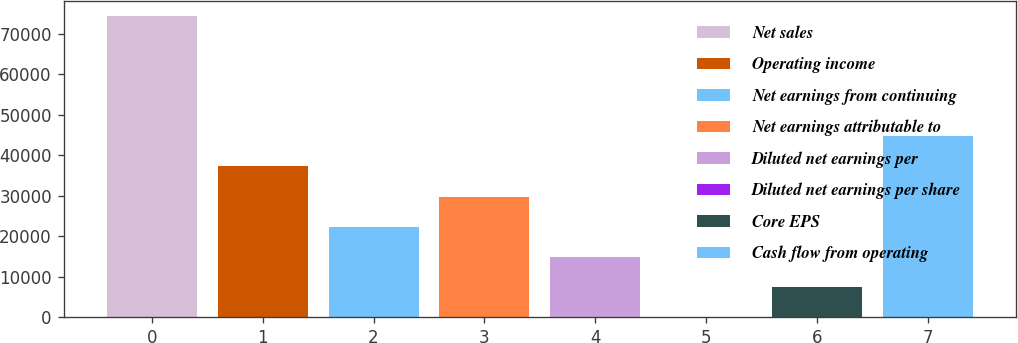Convert chart. <chart><loc_0><loc_0><loc_500><loc_500><bar_chart><fcel>Net sales<fcel>Operating income<fcel>Net earnings from continuing<fcel>Net earnings attributable to<fcel>Diluted net earnings per<fcel>Diluted net earnings per share<fcel>Core EPS<fcel>Cash flow from operating<nl><fcel>74401<fcel>37202.3<fcel>22322.8<fcel>29762.6<fcel>14883.1<fcel>3.63<fcel>7443.37<fcel>44642.1<nl></chart> 